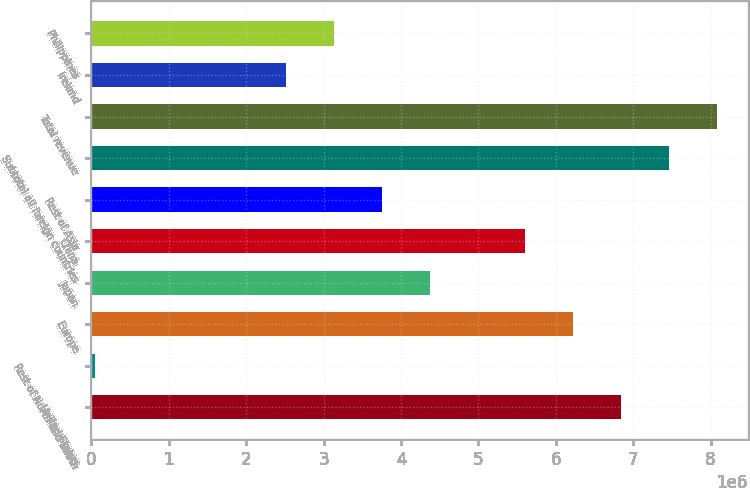Convert chart. <chart><loc_0><loc_0><loc_500><loc_500><bar_chart><fcel>United States<fcel>Rest of North and South<fcel>Europe<fcel>Japan<fcel>China<fcel>Rest of Asia<fcel>Subtotal all foreign countries<fcel>Total revenue<fcel>Ireland<fcel>Philippines<nl><fcel>6.84253e+06<fcel>46276<fcel>6.22469e+06<fcel>4.37117e+06<fcel>5.60685e+06<fcel>3.75332e+06<fcel>7.46037e+06<fcel>8.07821e+06<fcel>2.51764e+06<fcel>3.13548e+06<nl></chart> 